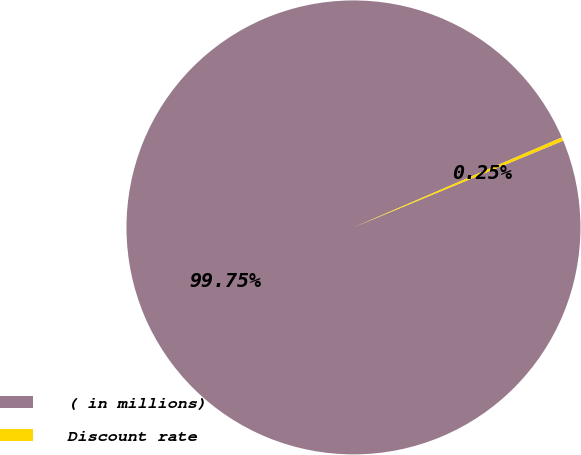Convert chart. <chart><loc_0><loc_0><loc_500><loc_500><pie_chart><fcel>( in millions)<fcel>Discount rate<nl><fcel>99.75%<fcel>0.25%<nl></chart> 